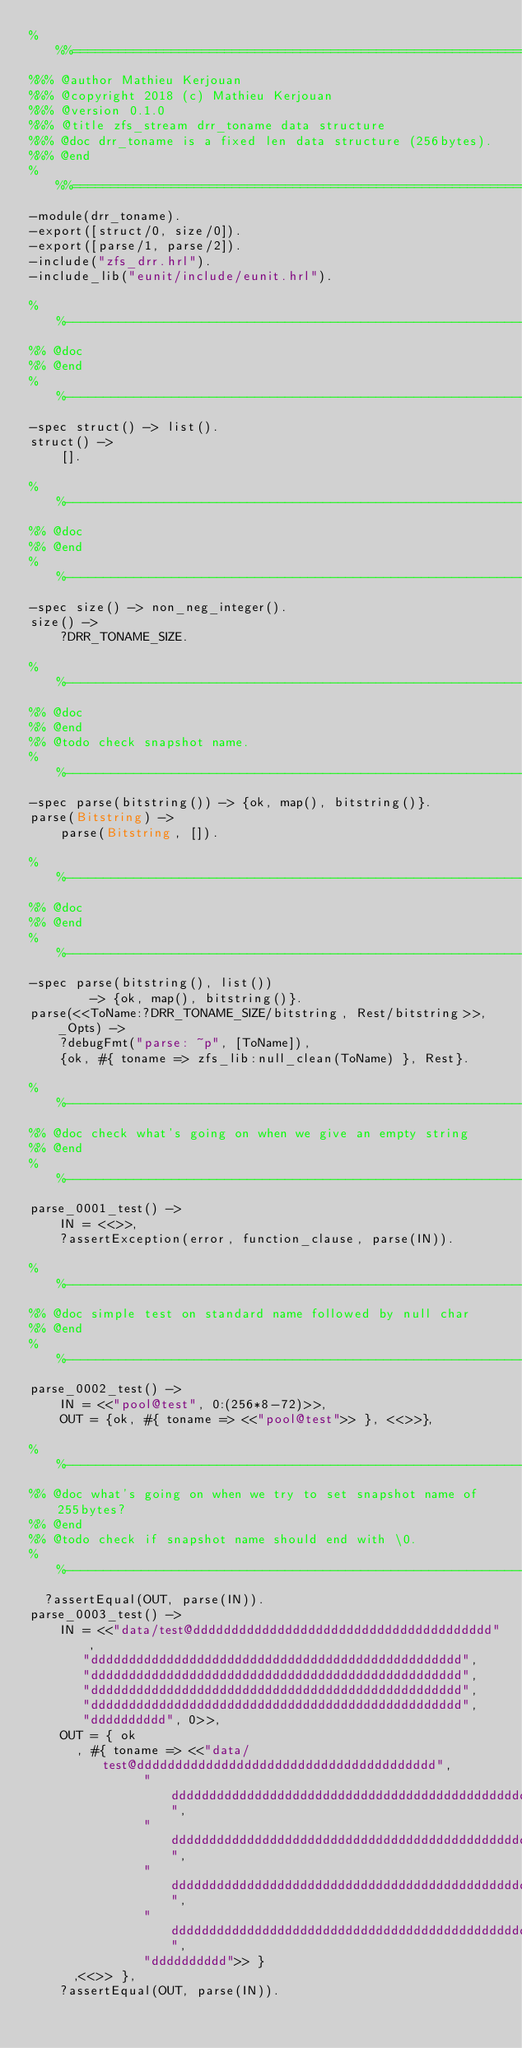<code> <loc_0><loc_0><loc_500><loc_500><_Erlang_>%%%===================================================================
%%% @author Mathieu Kerjouan
%%% @copyright 2018 (c) Mathieu Kerjouan
%%% @version 0.1.0
%%% @title zfs_stream drr_toname data structure
%%% @doc drr_toname is a fixed len data structure (256bytes).
%%% @end
%%%===================================================================
-module(drr_toname).
-export([struct/0, size/0]).
-export([parse/1, parse/2]).
-include("zfs_drr.hrl").
-include_lib("eunit/include/eunit.hrl").

%%--------------------------------------------------------------------
%% @doc
%% @end
%%--------------------------------------------------------------------
-spec struct() -> list().
struct() ->
    [].

%%--------------------------------------------------------------------
%% @doc
%% @end
%%--------------------------------------------------------------------
-spec size() -> non_neg_integer().
size() ->
    ?DRR_TONAME_SIZE.

%%--------------------------------------------------------------------
%% @doc
%% @end
%% @todo check snapshot name.
%%--------------------------------------------------------------------
-spec parse(bitstring()) -> {ok, map(), bitstring()}.
parse(Bitstring) ->
    parse(Bitstring, []).

%%--------------------------------------------------------------------
%% @doc
%% @end
%%--------------------------------------------------------------------
-spec parse(bitstring(), list())
        -> {ok, map(), bitstring()}.
parse(<<ToName:?DRR_TONAME_SIZE/bitstring, Rest/bitstring>>, _Opts) -> 
    ?debugFmt("parse: ~p", [ToName]),
    {ok, #{ toname => zfs_lib:null_clean(ToName) }, Rest}.

%%--------------------------------------------------------------------
%% @doc check what's going on when we give an empty string
%% @end
%%--------------------------------------------------------------------
parse_0001_test() ->
    IN = <<>>,
    ?assertException(error, function_clause, parse(IN)).

%%--------------------------------------------------------------------
%% @doc simple test on standard name followed by null char
%% @end
%%--------------------------------------------------------------------
parse_0002_test() ->
    IN = <<"pool@test", 0:(256*8-72)>>,
    OUT = {ok, #{ toname => <<"pool@test">> }, <<>>},

%%--------------------------------------------------------------------
%% @doc what's going on when we try to set snapshot name of 255bytes?
%% @end
%% @todo check if snapshot name should end with \0.
%%--------------------------------------------------------------------
  ?assertEqual(OUT, parse(IN)).
parse_0003_test() ->
    IN = <<"data/test@ddddddddddddddddddddddddddddddddddddddd",
	   "ddddddddddddddddddddddddddddddddddddddddddddddddd",
	   "ddddddddddddddddddddddddddddddddddddddddddddddddd",
	   "ddddddddddddddddddddddddddddddddddddddddddddddddd",
	   "ddddddddddddddddddddddddddddddddddddddddddddddddd",
	   "dddddddddd", 0>>,
    OUT = { ok
	  , #{ toname => <<"data/test@ddddddddddddddddddddddddddddddddddddddd",
			   "ddddddddddddddddddddddddddddddddddddddddddddddddd",
			   "ddddddddddddddddddddddddddddddddddddddddddddddddd",
			   "ddddddddddddddddddddddddddddddddddddddddddddddddd",
			   "ddddddddddddddddddddddddddddddddddddddddddddddddd",
			   "dddddddddd">> }
	  ,<<>> },
    ?assertEqual(OUT, parse(IN)).
</code> 